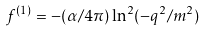<formula> <loc_0><loc_0><loc_500><loc_500>f ^ { ( 1 ) } = - ( \alpha / 4 \pi ) \ln ^ { 2 } ( - q ^ { 2 } / m ^ { 2 } )</formula> 